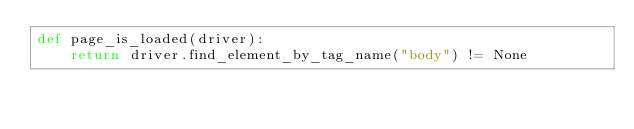Convert code to text. <code><loc_0><loc_0><loc_500><loc_500><_Python_>def page_is_loaded(driver):
    return driver.find_element_by_tag_name("body") != None
</code> 